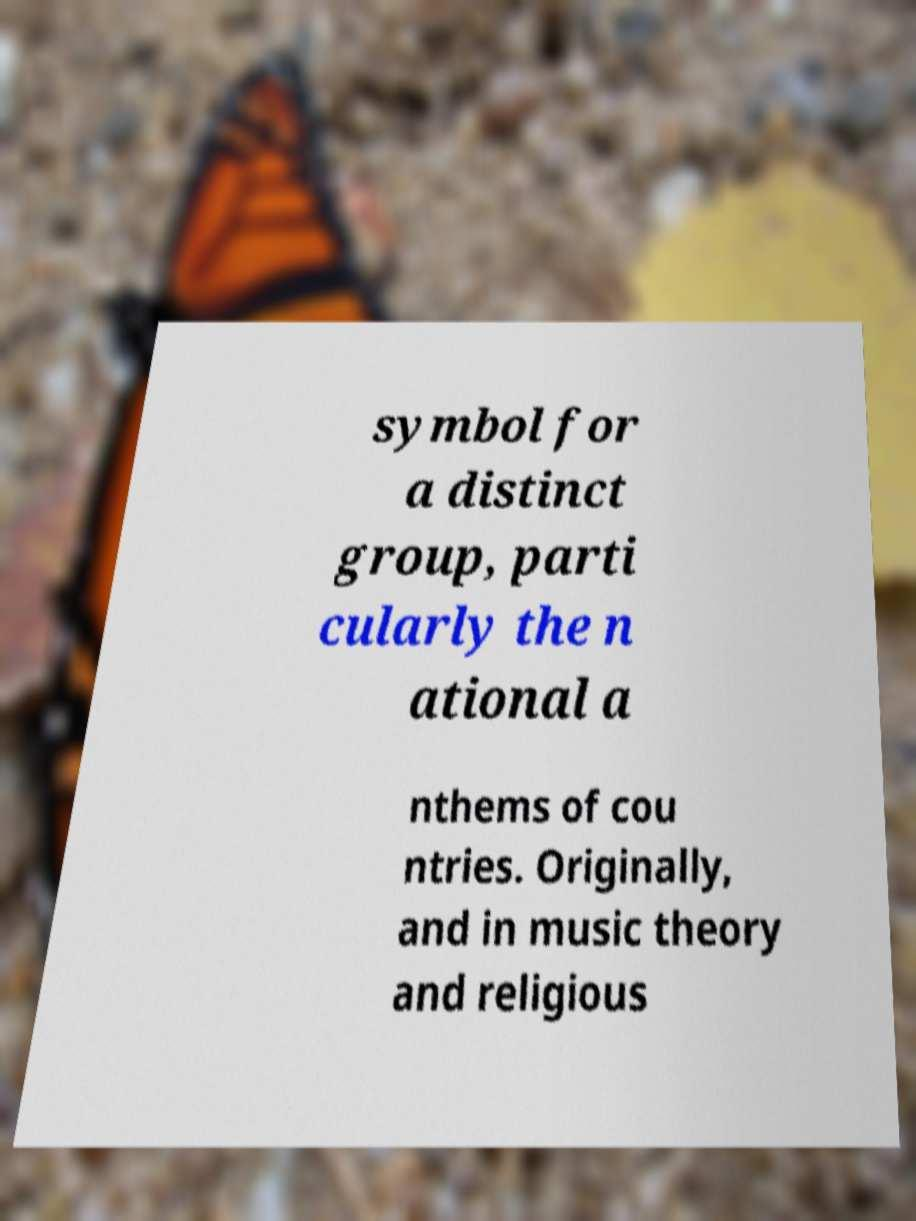Can you read and provide the text displayed in the image?This photo seems to have some interesting text. Can you extract and type it out for me? symbol for a distinct group, parti cularly the n ational a nthems of cou ntries. Originally, and in music theory and religious 